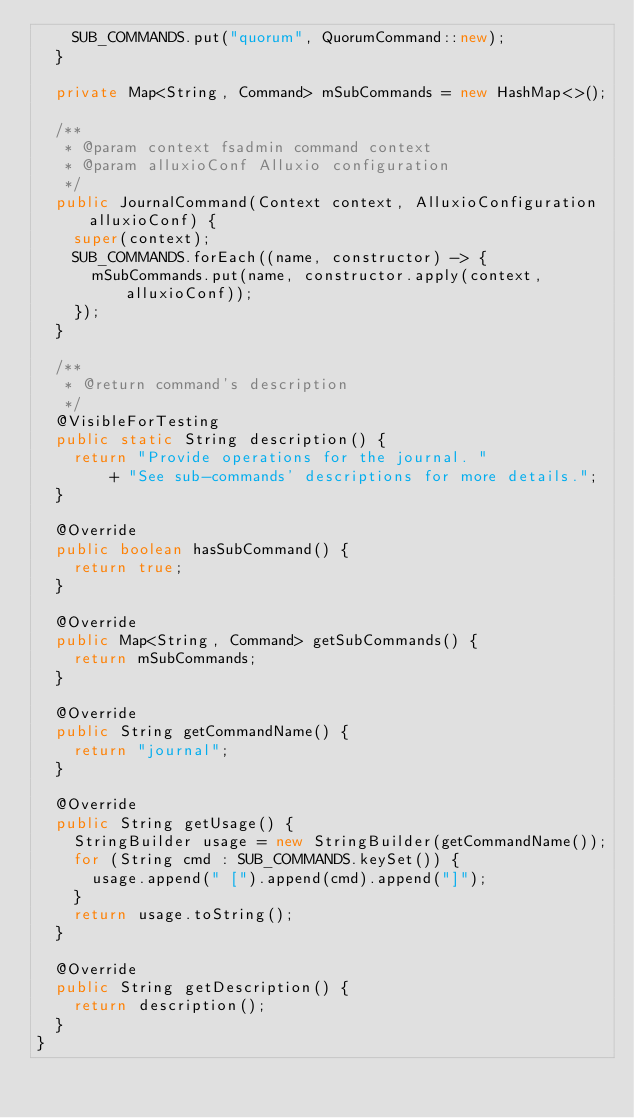Convert code to text. <code><loc_0><loc_0><loc_500><loc_500><_Java_>    SUB_COMMANDS.put("quorum", QuorumCommand::new);
  }

  private Map<String, Command> mSubCommands = new HashMap<>();

  /**
   * @param context fsadmin command context
   * @param alluxioConf Alluxio configuration
   */
  public JournalCommand(Context context, AlluxioConfiguration alluxioConf) {
    super(context);
    SUB_COMMANDS.forEach((name, constructor) -> {
      mSubCommands.put(name, constructor.apply(context, alluxioConf));
    });
  }

  /**
   * @return command's description
   */
  @VisibleForTesting
  public static String description() {
    return "Provide operations for the journal. "
        + "See sub-commands' descriptions for more details.";
  }

  @Override
  public boolean hasSubCommand() {
    return true;
  }

  @Override
  public Map<String, Command> getSubCommands() {
    return mSubCommands;
  }

  @Override
  public String getCommandName() {
    return "journal";
  }

  @Override
  public String getUsage() {
    StringBuilder usage = new StringBuilder(getCommandName());
    for (String cmd : SUB_COMMANDS.keySet()) {
      usage.append(" [").append(cmd).append("]");
    }
    return usage.toString();
  }

  @Override
  public String getDescription() {
    return description();
  }
}
</code> 